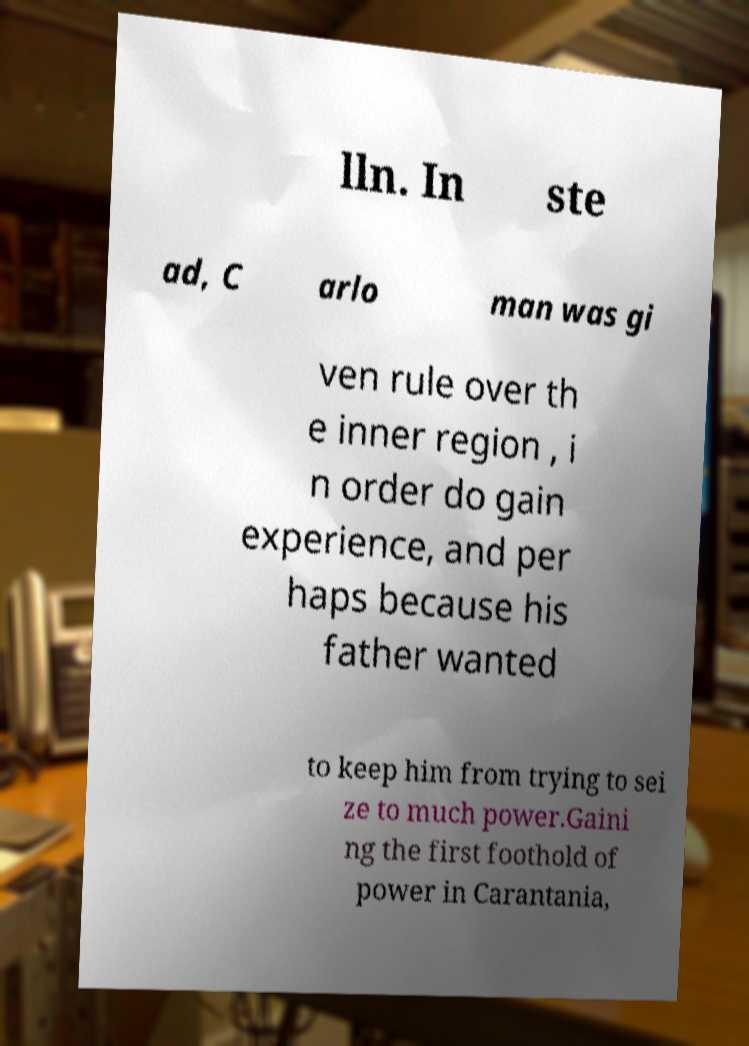Could you assist in decoding the text presented in this image and type it out clearly? lln. In ste ad, C arlo man was gi ven rule over th e inner region , i n order do gain experience, and per haps because his father wanted to keep him from trying to sei ze to much power.Gaini ng the first foothold of power in Carantania, 